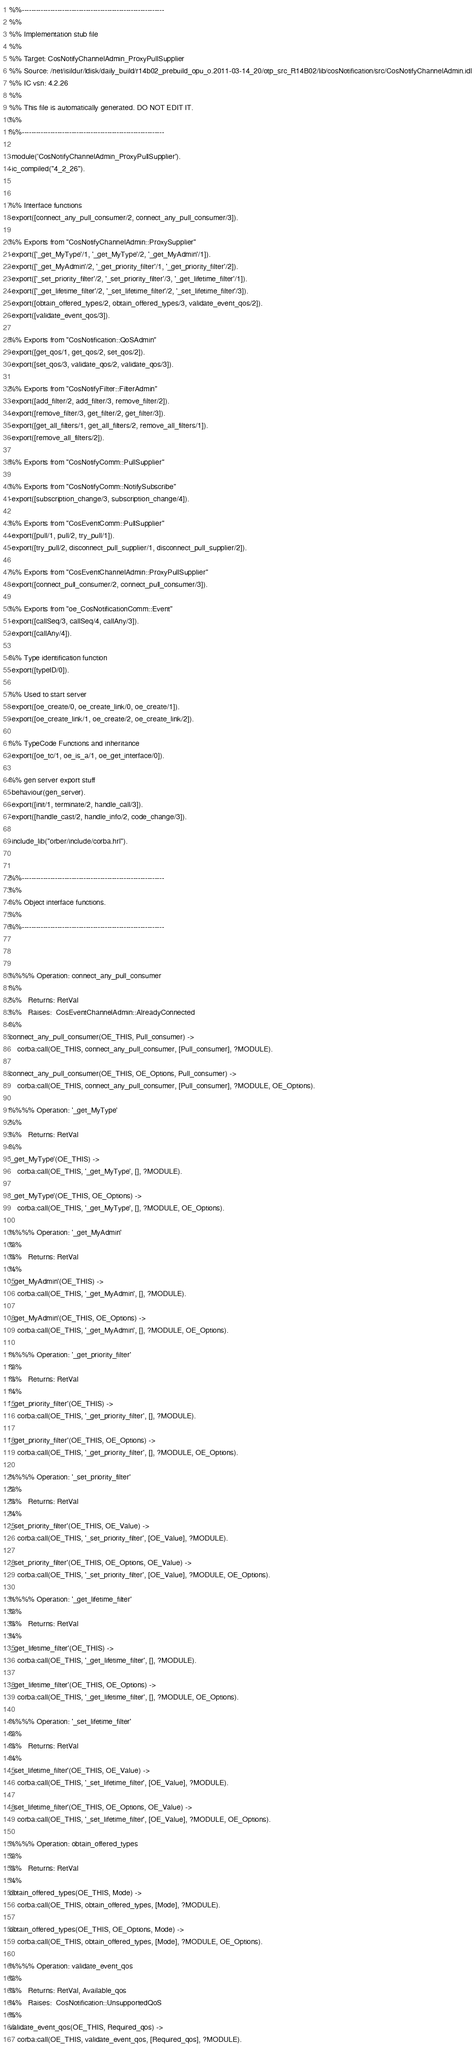<code> <loc_0><loc_0><loc_500><loc_500><_Erlang_>%%------------------------------------------------------------
%%
%% Implementation stub file
%% 
%% Target: CosNotifyChannelAdmin_ProxyPullSupplier
%% Source: /net/isildur/ldisk/daily_build/r14b02_prebuild_opu_o.2011-03-14_20/otp_src_R14B02/lib/cosNotification/src/CosNotifyChannelAdmin.idl
%% IC vsn: 4.2.26
%% 
%% This file is automatically generated. DO NOT EDIT IT.
%%
%%------------------------------------------------------------

-module('CosNotifyChannelAdmin_ProxyPullSupplier').
-ic_compiled("4_2_26").


%% Interface functions
-export([connect_any_pull_consumer/2, connect_any_pull_consumer/3]).

%% Exports from "CosNotifyChannelAdmin::ProxySupplier"
-export(['_get_MyType'/1, '_get_MyType'/2, '_get_MyAdmin'/1]).
-export(['_get_MyAdmin'/2, '_get_priority_filter'/1, '_get_priority_filter'/2]).
-export(['_set_priority_filter'/2, '_set_priority_filter'/3, '_get_lifetime_filter'/1]).
-export(['_get_lifetime_filter'/2, '_set_lifetime_filter'/2, '_set_lifetime_filter'/3]).
-export([obtain_offered_types/2, obtain_offered_types/3, validate_event_qos/2]).
-export([validate_event_qos/3]).

%% Exports from "CosNotification::QoSAdmin"
-export([get_qos/1, get_qos/2, set_qos/2]).
-export([set_qos/3, validate_qos/2, validate_qos/3]).

%% Exports from "CosNotifyFilter::FilterAdmin"
-export([add_filter/2, add_filter/3, remove_filter/2]).
-export([remove_filter/3, get_filter/2, get_filter/3]).
-export([get_all_filters/1, get_all_filters/2, remove_all_filters/1]).
-export([remove_all_filters/2]).

%% Exports from "CosNotifyComm::PullSupplier"

%% Exports from "CosNotifyComm::NotifySubscribe"
-export([subscription_change/3, subscription_change/4]).

%% Exports from "CosEventComm::PullSupplier"
-export([pull/1, pull/2, try_pull/1]).
-export([try_pull/2, disconnect_pull_supplier/1, disconnect_pull_supplier/2]).

%% Exports from "CosEventChannelAdmin::ProxyPullSupplier"
-export([connect_pull_consumer/2, connect_pull_consumer/3]).

%% Exports from "oe_CosNotificationComm::Event"
-export([callSeq/3, callSeq/4, callAny/3]).
-export([callAny/4]).

%% Type identification function
-export([typeID/0]).

%% Used to start server
-export([oe_create/0, oe_create_link/0, oe_create/1]).
-export([oe_create_link/1, oe_create/2, oe_create_link/2]).

%% TypeCode Functions and inheritance
-export([oe_tc/1, oe_is_a/1, oe_get_interface/0]).

%% gen server export stuff
-behaviour(gen_server).
-export([init/1, terminate/2, handle_call/3]).
-export([handle_cast/2, handle_info/2, code_change/3]).

-include_lib("orber/include/corba.hrl").


%%------------------------------------------------------------
%%
%% Object interface functions.
%%
%%------------------------------------------------------------



%%%% Operation: connect_any_pull_consumer
%% 
%%   Returns: RetVal
%%   Raises:  CosEventChannelAdmin::AlreadyConnected
%%
connect_any_pull_consumer(OE_THIS, Pull_consumer) ->
    corba:call(OE_THIS, connect_any_pull_consumer, [Pull_consumer], ?MODULE).

connect_any_pull_consumer(OE_THIS, OE_Options, Pull_consumer) ->
    corba:call(OE_THIS, connect_any_pull_consumer, [Pull_consumer], ?MODULE, OE_Options).

%%%% Operation: '_get_MyType'
%% 
%%   Returns: RetVal
%%
'_get_MyType'(OE_THIS) ->
    corba:call(OE_THIS, '_get_MyType', [], ?MODULE).

'_get_MyType'(OE_THIS, OE_Options) ->
    corba:call(OE_THIS, '_get_MyType', [], ?MODULE, OE_Options).

%%%% Operation: '_get_MyAdmin'
%% 
%%   Returns: RetVal
%%
'_get_MyAdmin'(OE_THIS) ->
    corba:call(OE_THIS, '_get_MyAdmin', [], ?MODULE).

'_get_MyAdmin'(OE_THIS, OE_Options) ->
    corba:call(OE_THIS, '_get_MyAdmin', [], ?MODULE, OE_Options).

%%%% Operation: '_get_priority_filter'
%% 
%%   Returns: RetVal
%%
'_get_priority_filter'(OE_THIS) ->
    corba:call(OE_THIS, '_get_priority_filter', [], ?MODULE).

'_get_priority_filter'(OE_THIS, OE_Options) ->
    corba:call(OE_THIS, '_get_priority_filter', [], ?MODULE, OE_Options).

%%%% Operation: '_set_priority_filter'
%% 
%%   Returns: RetVal
%%
'_set_priority_filter'(OE_THIS, OE_Value) ->
    corba:call(OE_THIS, '_set_priority_filter', [OE_Value], ?MODULE).

'_set_priority_filter'(OE_THIS, OE_Options, OE_Value) ->
    corba:call(OE_THIS, '_set_priority_filter', [OE_Value], ?MODULE, OE_Options).

%%%% Operation: '_get_lifetime_filter'
%% 
%%   Returns: RetVal
%%
'_get_lifetime_filter'(OE_THIS) ->
    corba:call(OE_THIS, '_get_lifetime_filter', [], ?MODULE).

'_get_lifetime_filter'(OE_THIS, OE_Options) ->
    corba:call(OE_THIS, '_get_lifetime_filter', [], ?MODULE, OE_Options).

%%%% Operation: '_set_lifetime_filter'
%% 
%%   Returns: RetVal
%%
'_set_lifetime_filter'(OE_THIS, OE_Value) ->
    corba:call(OE_THIS, '_set_lifetime_filter', [OE_Value], ?MODULE).

'_set_lifetime_filter'(OE_THIS, OE_Options, OE_Value) ->
    corba:call(OE_THIS, '_set_lifetime_filter', [OE_Value], ?MODULE, OE_Options).

%%%% Operation: obtain_offered_types
%% 
%%   Returns: RetVal
%%
obtain_offered_types(OE_THIS, Mode) ->
    corba:call(OE_THIS, obtain_offered_types, [Mode], ?MODULE).

obtain_offered_types(OE_THIS, OE_Options, Mode) ->
    corba:call(OE_THIS, obtain_offered_types, [Mode], ?MODULE, OE_Options).

%%%% Operation: validate_event_qos
%% 
%%   Returns: RetVal, Available_qos
%%   Raises:  CosNotification::UnsupportedQoS
%%
validate_event_qos(OE_THIS, Required_qos) ->
    corba:call(OE_THIS, validate_event_qos, [Required_qos], ?MODULE).
</code> 